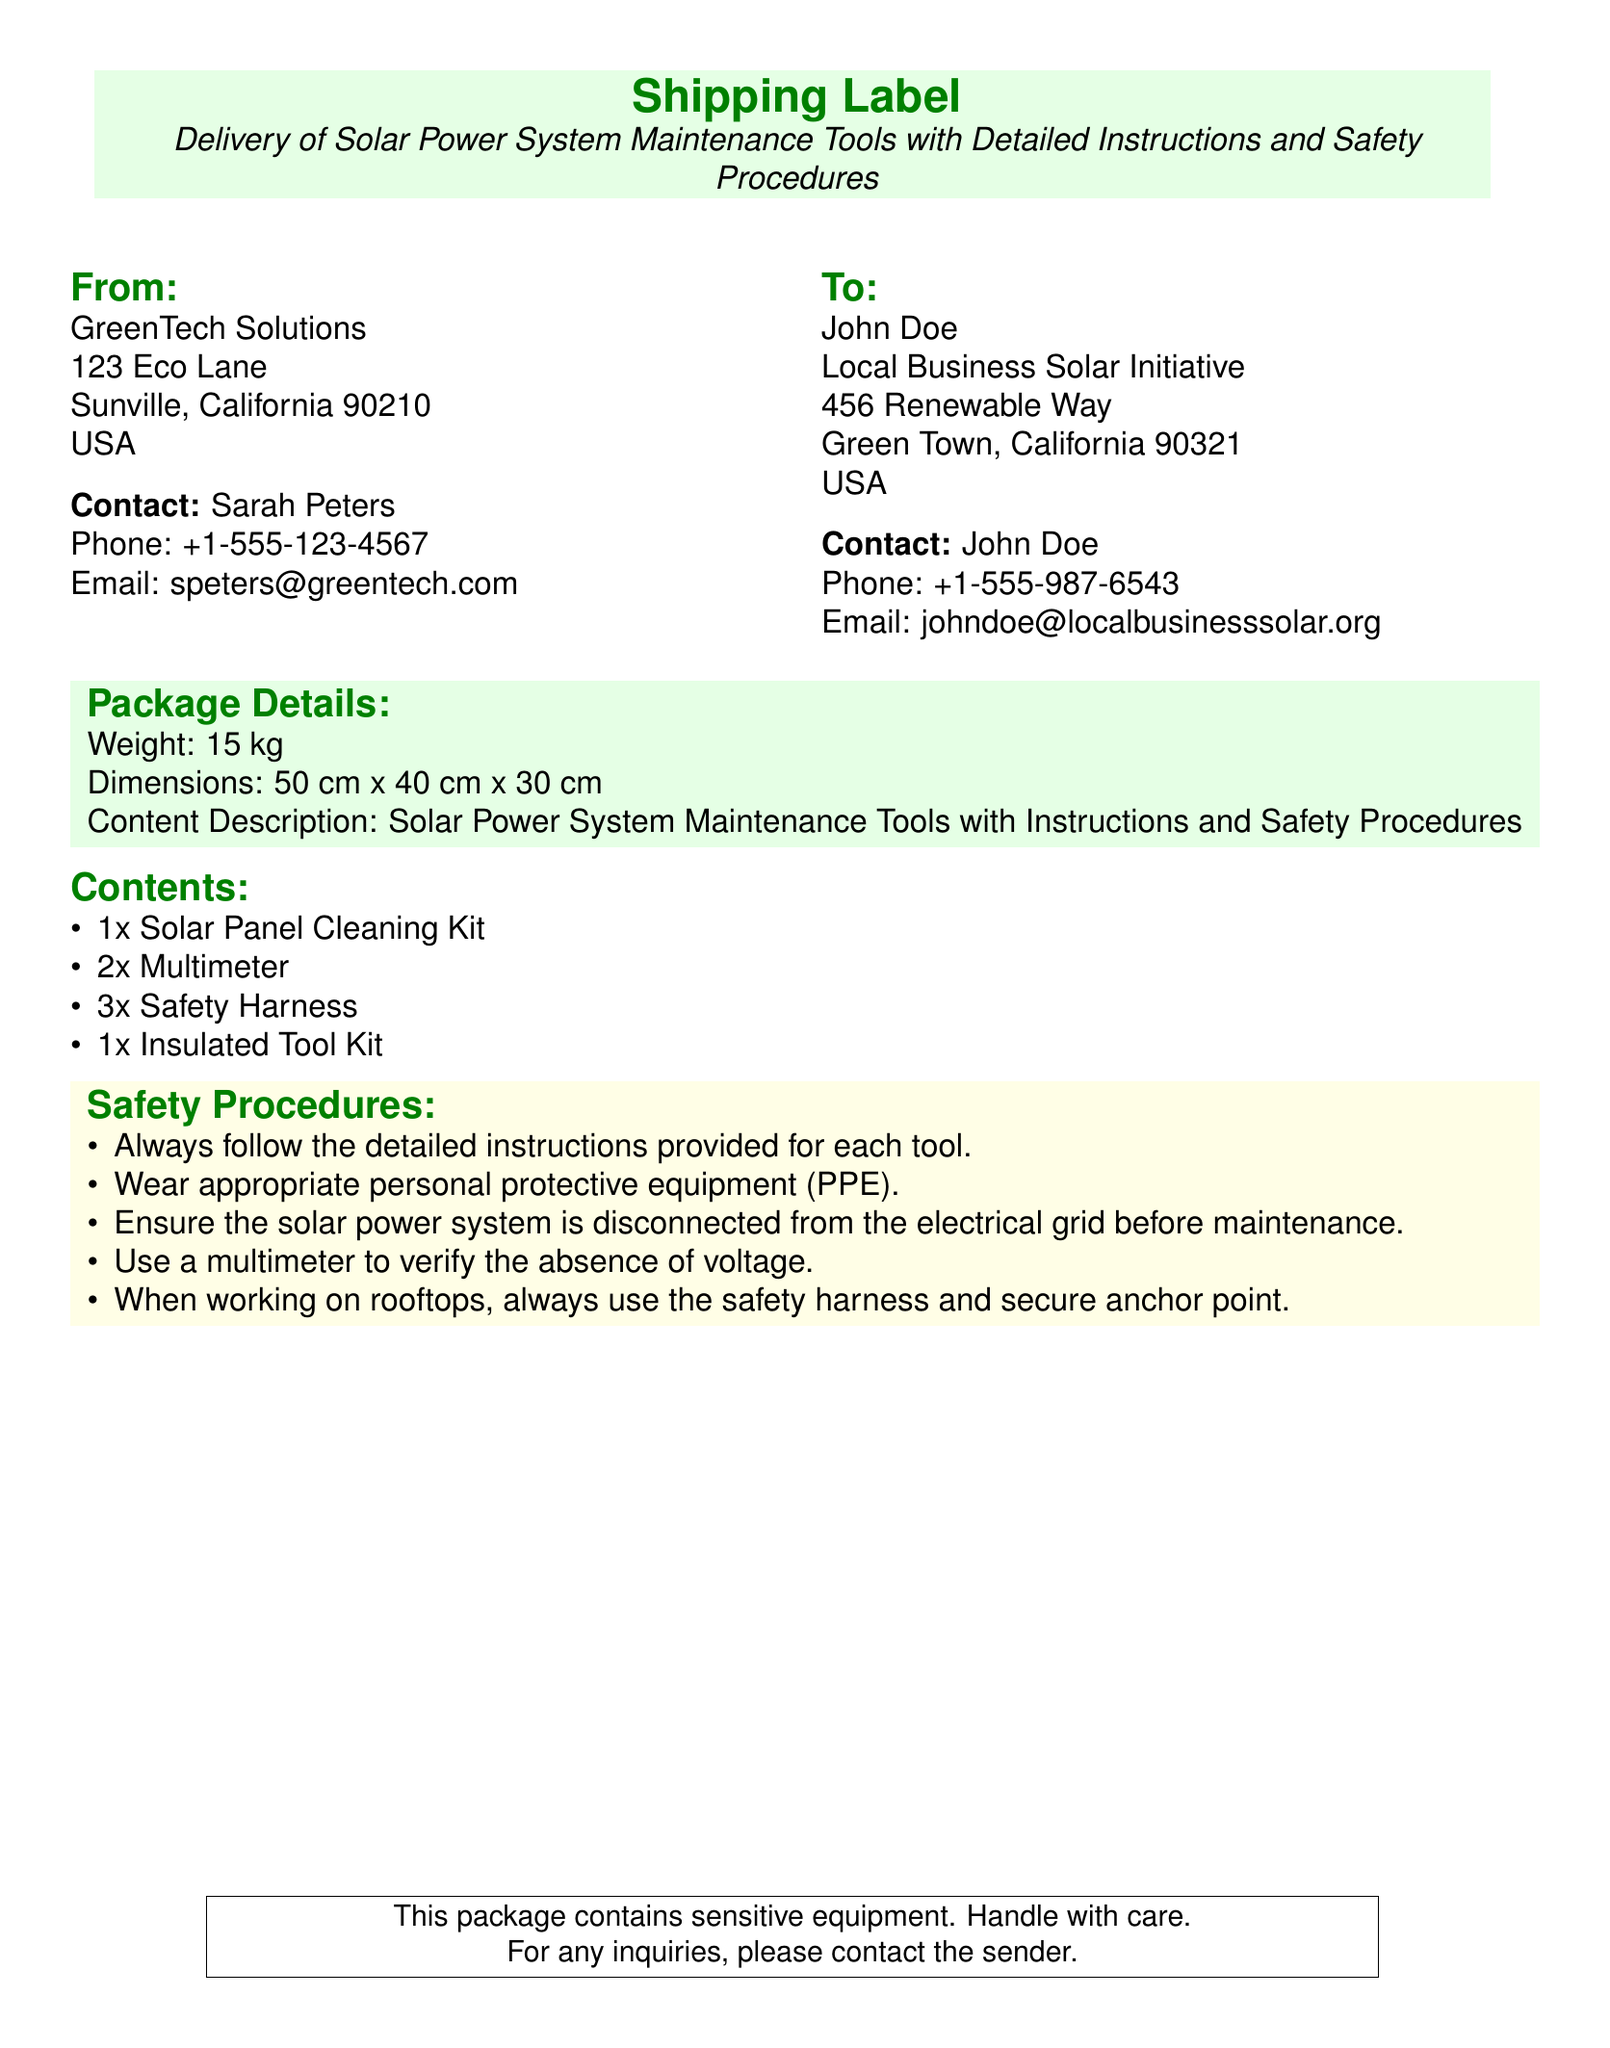What is the name of the sender? The sender is GreenTech Solutions, as listed in the "From" section of the document.
Answer: GreenTech Solutions What is the contact phone number for the sender? The document provides the specific phone number for the sender, which is +1-555-123-4567.
Answer: +1-555-123-4567 What is the weight of the package? The weight of the package is mentioned directly in the "Package Details" section as 15 kg.
Answer: 15 kg How many solar panel cleaning kits are included? The document lists the contents and specifies that there is 1 solar panel cleaning kit.
Answer: 1x Solar Panel Cleaning Kit What is one of the safety procedures mentioned? The document contains a list of safety procedures, and one of them is to always follow the detailed instructions provided for each tool.
Answer: Always follow the detailed instructions provided for each tool What ensures that the system is safe to maintain? To ensure safety, it is advised to use a multimeter to verify the absence of voltage before maintenance.
Answer: Use a multimeter to verify the absence of voltage Who is the recipient of the package? The recipient's name is stated clearly in the "To" section of the document as John Doe.
Answer: John Doe How many multimeters are included in the package? The contents list specifies there are 2 multimeters included in the package.
Answer: 2x Multimeter What should be worn while working on rooftops? The document states that a safety harness should be worn when working on rooftops, to ensure safety.
Answer: Safety harness 